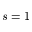<formula> <loc_0><loc_0><loc_500><loc_500>s = 1</formula> 